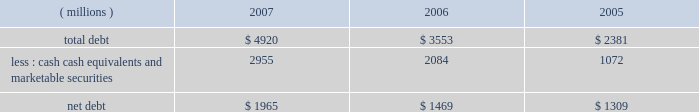New accounting pronouncements information regarding new accounting pronouncements is included in note 1 to the consolidated financial statements .
Financial condition and liquidity the company generates significant ongoing cash flow .
Increases in long-term debt have been used , in part , to fund share repurchase activities and acquisitions .
On november 15 , 2007 , 3m ( safety , security and protection services business ) announced that it had entered into a definitive agreement for 3m 2019s acquisition of 100 percent of the outstanding shares of aearo holding corp .
E83a a global leader in the personal protection industry that manufactures and markets personal protection and energy absorbing products e83a for approximately $ 1.2 billion .
The sale is expected to close towards the end of the first quarter of 2008 .
At december 31 .
Cash , cash equivalents and marketable securities at december 31 , 2007 totaled approximately $ 3 billion , helped by strong cash flow generation and by the timing of debt issuances .
At december 31 , 2006 , cash balances were higher due to the significant pharmaceuticals sales proceeds received in december 2006 .
3m believes its ongoing cash flows provide ample cash to fund expected investments and capital expenditures .
The company has sufficient access to capital markets to meet currently anticipated growth and acquisition investment funding needs .
The company does not utilize derivative instruments linked to the company 2019s stock .
However , the company does have contingently convertible debt that , if conditions for conversion are met , is convertible into shares of 3m common stock ( refer to note 10 in this document ) .
The company 2019s financial condition and liquidity are strong .
Various assets and liabilities , including cash and short-term debt , can fluctuate significantly from month to month depending on short-term liquidity needs .
Working capital ( defined as current assets minus current liabilities ) totaled $ 4.476 billion at december 31 , 2007 , compared with $ 1.623 billion at december 31 , 2006 .
Working capital was higher primarily due to increases in cash and cash equivalents , short-term marketable securities , receivables and inventories and decreases in short-term debt and accrued income taxes .
The company 2019s liquidity remains strong , with cash , cash equivalents and marketable securities at december 31 , 2007 totaling approximately $ 3 billion .
Primary short-term liquidity needs are provided through u.s .
Commercial paper and euro commercial paper issuances .
As of december 31 , 2007 , outstanding total commercial paper issued totaled $ 349 million and averaged $ 1.249 billion during 2007 .
The company believes it unlikely that its access to the commercial paper market will be restricted .
In june 2007 , the company established a medium-term notes program through which up to $ 3 billion of medium-term notes may be offered , with remaining shelf borrowing capacity of $ 2.5 billion as of december 31 , 2007 .
On april 30 , 2007 , the company replaced its $ 565-million credit facility with a new $ 1.5-billion five-year credit facility , which has provisions for the company to request an increase of the facility up to $ 2 billion ( at the lenders 2019 discretion ) , and providing for up to $ 150 million in letters of credit .
As of december 31 , 2007 , there are $ 110 million in letters of credit drawn against the facility .
At december 31 , 2007 , available short-term committed lines of credit internationally totaled approximately $ 67 million , of which $ 13 million was utilized .
Debt covenants do not restrict the payment of dividends .
The company has a "well-known seasoned issuer" shelf registration statement , effective february 24 , 2006 , to register an indeterminate amount of debt or equity securities for future sales .
The company intends to use the proceeds from future securities sales off this shelf for general corporate purposes .
At december 31 , 2007 , certain debt agreements ( $ 350 million of dealer remarketable securities and $ 87 million of esop debt ) had ratings triggers ( bbb-/baa3 or lower ) that would require repayment of debt .
The company has an aa credit rating , with a stable outlook , from standard & poor 2019s and an aa1 credit rating , with a negative outlook , from moody 2019s investors service .
In addition , under the $ 1.5-billion five-year credit facility agreement , 3m is required to maintain its ebitda to interest ratio as of the end of each fiscal quarter at not less than 3.0 to 1 .
This is calculated ( as defined in the agreement ) as the ratio of consolidated total ebitda for the four consecutive quarters then ended to total interest expense on all funded debt for the same period .
At december 31 , 2007 , this ratio was approximately 35 to 1. .
What was the percentage change in the working capital from 2006 to 2007? 
Rationale: the working capital increased by 176% from 2006 to 2007
Computations: ((4.476 - 1.623) / 1.623)
Answer: 1.75786. 